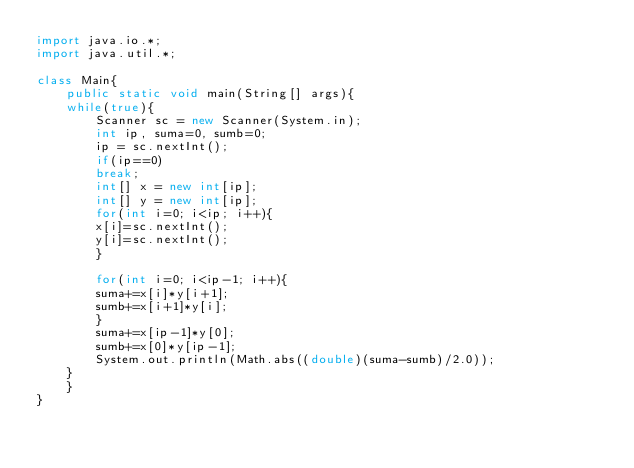Convert code to text. <code><loc_0><loc_0><loc_500><loc_500><_Java_>import java.io.*;
import java.util.*;

class Main{
    public static void main(String[] args){
	while(true){
	    Scanner sc = new Scanner(System.in);
	    int ip, suma=0, sumb=0;
	    ip = sc.nextInt();
	    if(ip==0)
		break;
	    int[] x = new int[ip];
	    int[] y = new int[ip];
	    for(int i=0; i<ip; i++){
		x[i]=sc.nextInt();
		y[i]=sc.nextInt();
	    }
	    
	    for(int i=0; i<ip-1; i++){
		suma+=x[i]*y[i+1];
		sumb+=x[i+1]*y[i];
	    }
	    suma+=x[ip-1]*y[0];
	    sumb+=x[0]*y[ip-1];
	    System.out.println(Math.abs((double)(suma-sumb)/2.0));
	}
    }
}</code> 